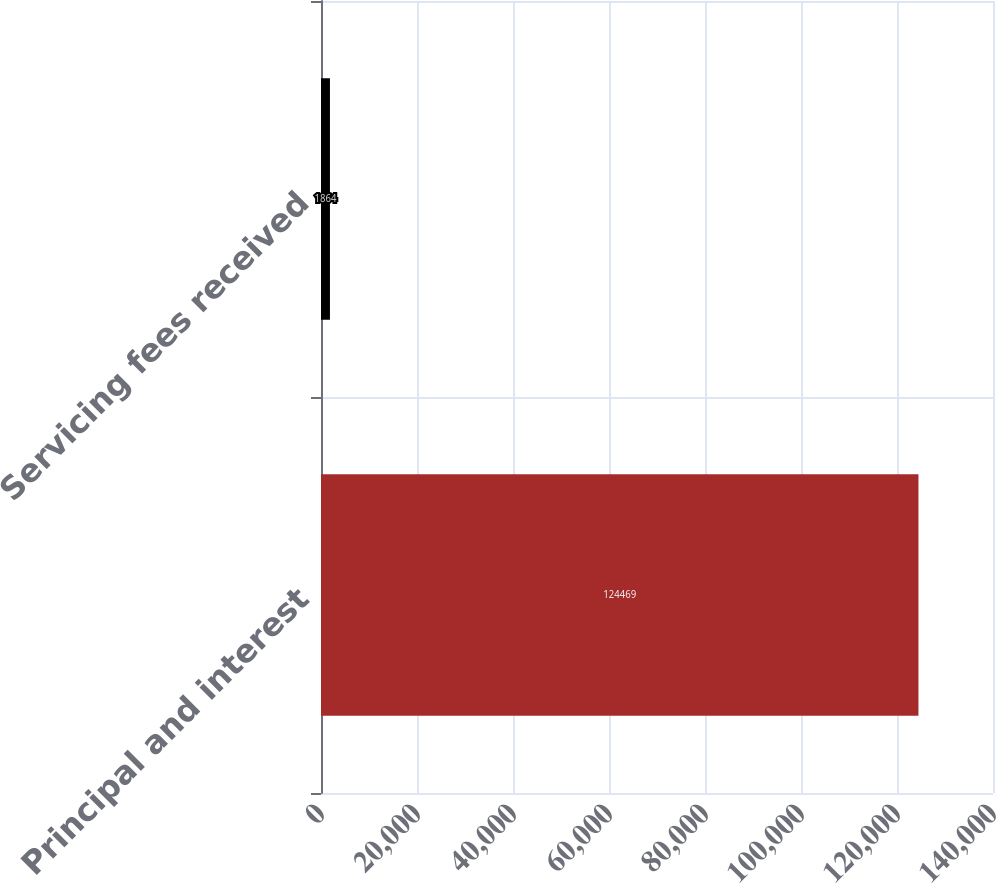Convert chart to OTSL. <chart><loc_0><loc_0><loc_500><loc_500><bar_chart><fcel>Principal and interest<fcel>Servicing fees received<nl><fcel>124469<fcel>1864<nl></chart> 